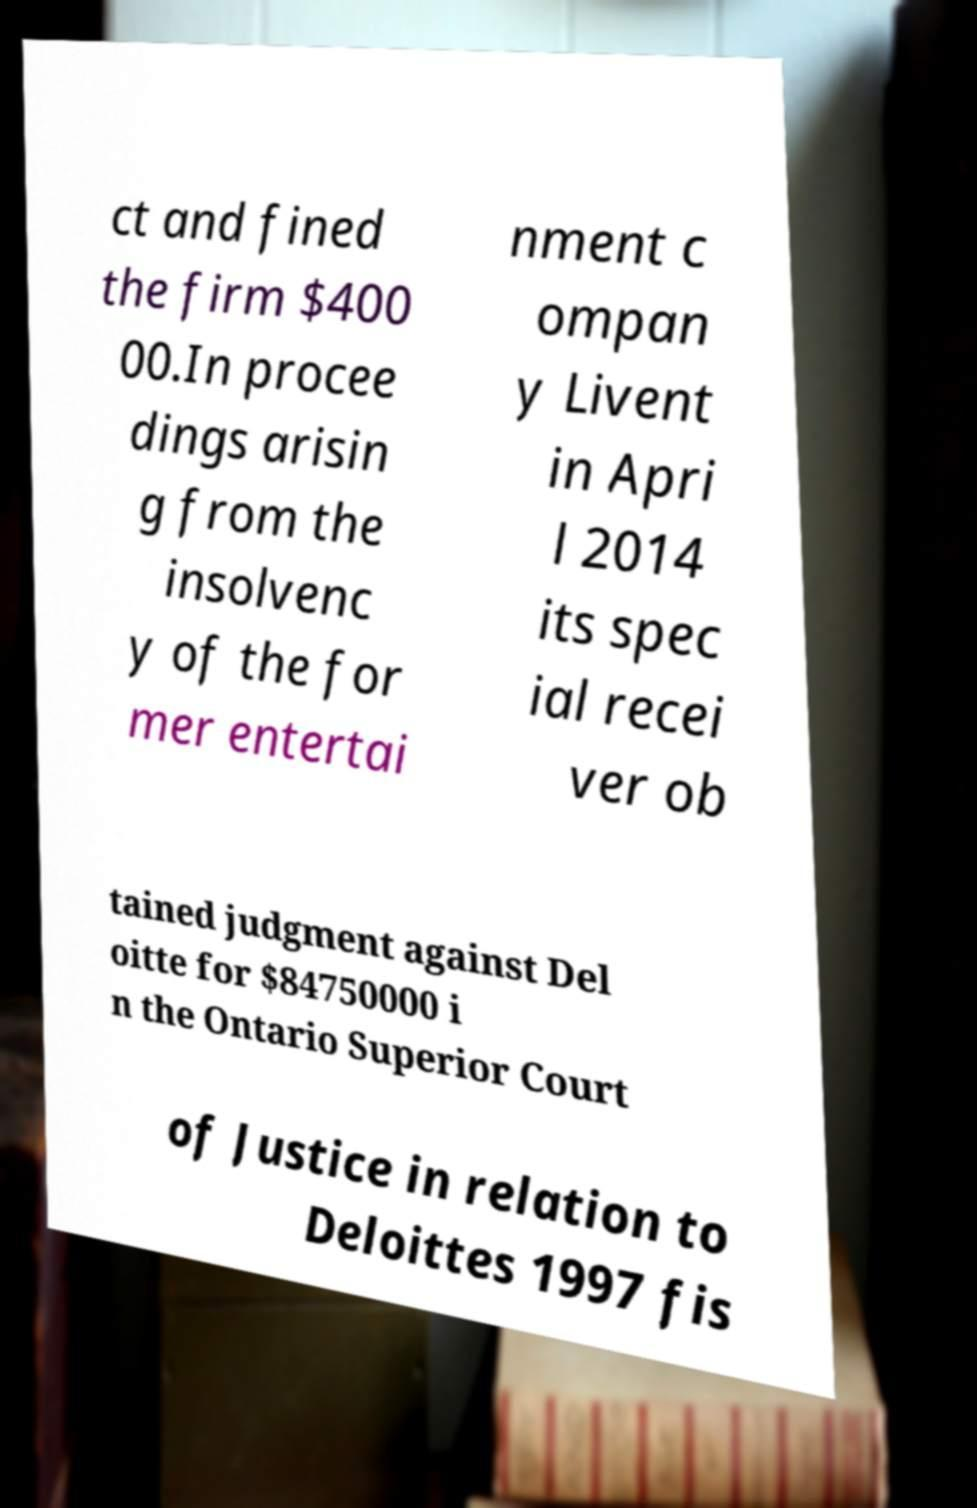Please identify and transcribe the text found in this image. ct and fined the firm $400 00.In procee dings arisin g from the insolvenc y of the for mer entertai nment c ompan y Livent in Apri l 2014 its spec ial recei ver ob tained judgment against Del oitte for $84750000 i n the Ontario Superior Court of Justice in relation to Deloittes 1997 fis 